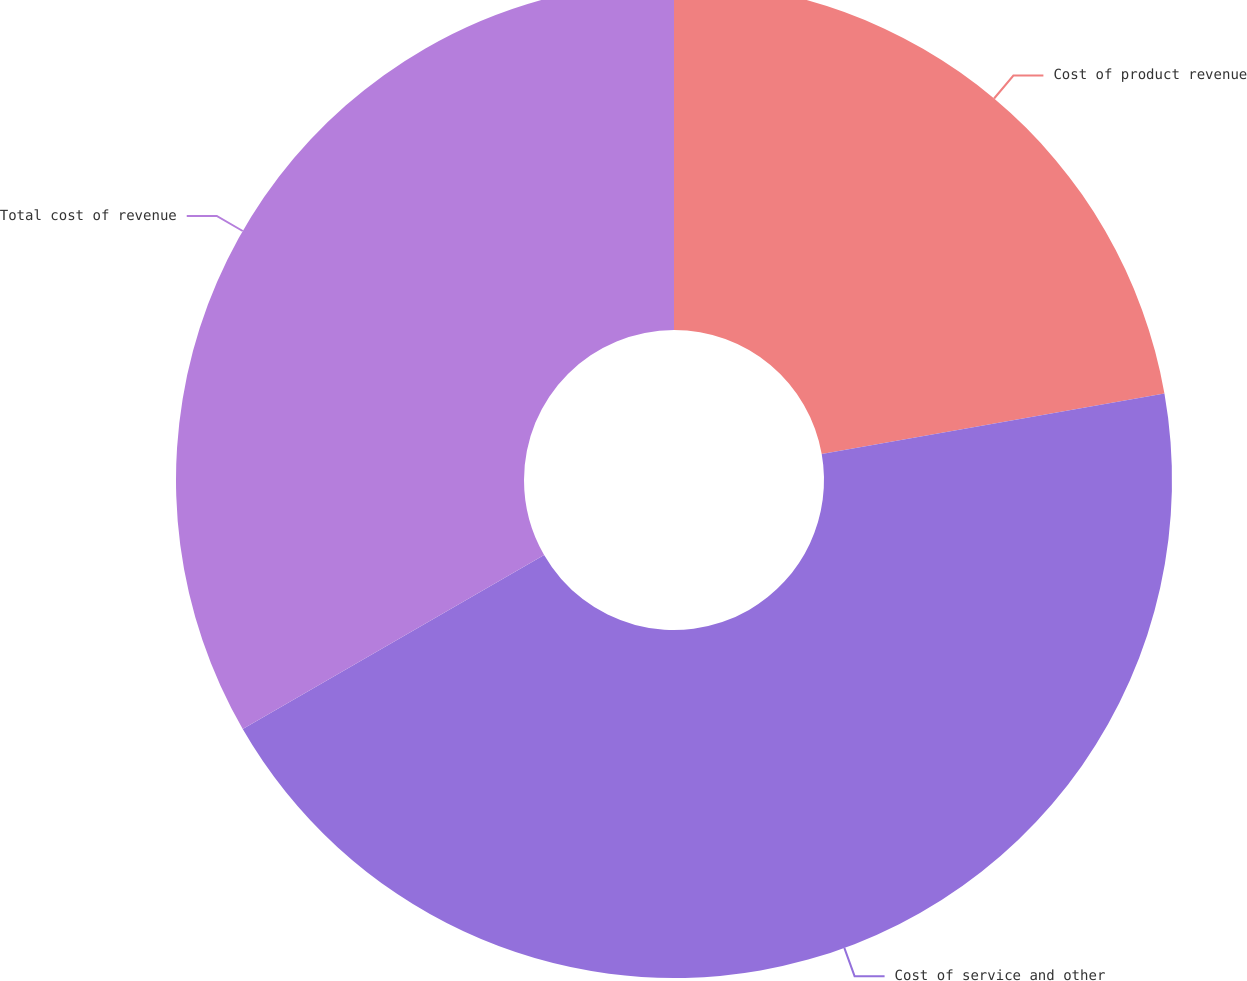<chart> <loc_0><loc_0><loc_500><loc_500><pie_chart><fcel>Cost of product revenue<fcel>Cost of service and other<fcel>Total cost of revenue<nl><fcel>22.22%<fcel>44.44%<fcel>33.33%<nl></chart> 